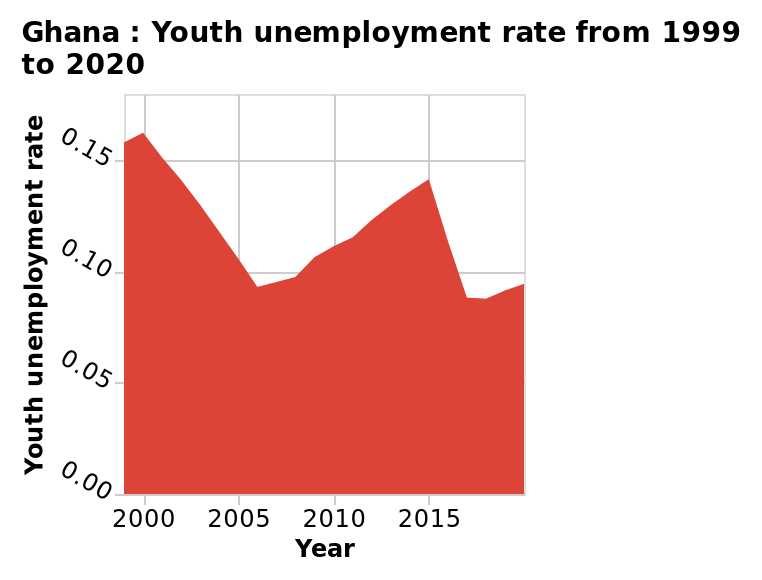<image>
please describe the details of the chart Here a is a area graph called Ghana : Youth unemployment rate from 1999 to 2020. A scale of range 0.00 to 0.15 can be found on the y-axis, marked Youth unemployment rate. There is a linear scale with a minimum of 2000 and a maximum of 2015 on the x-axis, labeled Year. Did the unemployment rate show a smooth downwards curve from 2000 to 2015?  No, the unemployment rate did not show a smooth downwards curve. It was a jagged line, going down and then up again. 